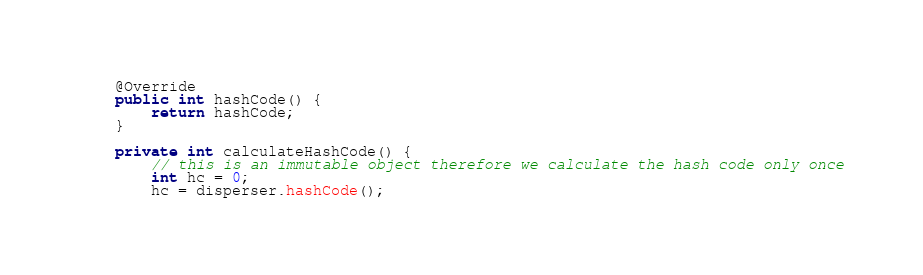Convert code to text. <code><loc_0><loc_0><loc_500><loc_500><_Java_>    @Override
    public int hashCode() {
        return hashCode;
    }

    private int calculateHashCode() {
        // this is an immutable object therefore we calculate the hash code only once
        int hc = 0;
        hc = disperser.hashCode();</code> 